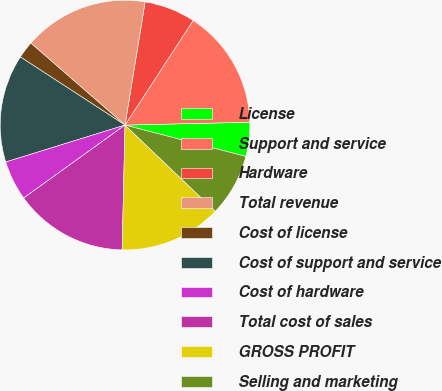Convert chart to OTSL. <chart><loc_0><loc_0><loc_500><loc_500><pie_chart><fcel>License<fcel>Support and service<fcel>Hardware<fcel>Total revenue<fcel>Cost of license<fcel>Cost of support and service<fcel>Cost of hardware<fcel>Total cost of sales<fcel>GROSS PROFIT<fcel>Selling and marketing<nl><fcel>4.41%<fcel>15.44%<fcel>6.62%<fcel>16.18%<fcel>2.21%<fcel>13.97%<fcel>5.15%<fcel>14.71%<fcel>13.24%<fcel>8.09%<nl></chart> 